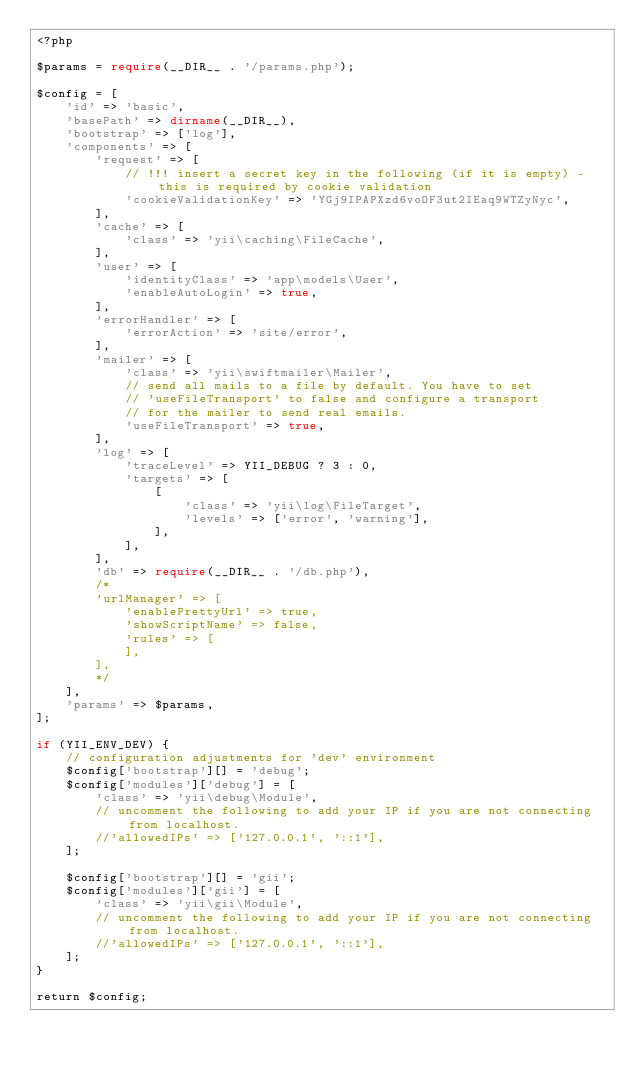<code> <loc_0><loc_0><loc_500><loc_500><_PHP_><?php

$params = require(__DIR__ . '/params.php');

$config = [
    'id' => 'basic',
    'basePath' => dirname(__DIR__),
    'bootstrap' => ['log'],
    'components' => [
        'request' => [
            // !!! insert a secret key in the following (if it is empty) - this is required by cookie validation
            'cookieValidationKey' => 'YGj9IPAPXzd6voOF3ut2IEaq9WTZyNyc',
        ],
        'cache' => [
            'class' => 'yii\caching\FileCache',
        ],
        'user' => [
            'identityClass' => 'app\models\User',
            'enableAutoLogin' => true,
        ],
        'errorHandler' => [
            'errorAction' => 'site/error',
        ],
        'mailer' => [
            'class' => 'yii\swiftmailer\Mailer',
            // send all mails to a file by default. You have to set
            // 'useFileTransport' to false and configure a transport
            // for the mailer to send real emails.
            'useFileTransport' => true,
        ],
        'log' => [
            'traceLevel' => YII_DEBUG ? 3 : 0,
            'targets' => [
                [
                    'class' => 'yii\log\FileTarget',
                    'levels' => ['error', 'warning'],
                ],
            ],
        ],
        'db' => require(__DIR__ . '/db.php'),
        /*
        'urlManager' => [
            'enablePrettyUrl' => true,
            'showScriptName' => false,
            'rules' => [
            ],
        ],
        */
    ],
    'params' => $params,
];

if (YII_ENV_DEV) {
    // configuration adjustments for 'dev' environment
    $config['bootstrap'][] = 'debug';
    $config['modules']['debug'] = [
        'class' => 'yii\debug\Module',
        // uncomment the following to add your IP if you are not connecting from localhost.
        //'allowedIPs' => ['127.0.0.1', '::1'],
    ];

    $config['bootstrap'][] = 'gii';
    $config['modules']['gii'] = [
        'class' => 'yii\gii\Module',
        // uncomment the following to add your IP if you are not connecting from localhost.
        //'allowedIPs' => ['127.0.0.1', '::1'],
    ];
}

return $config;
</code> 